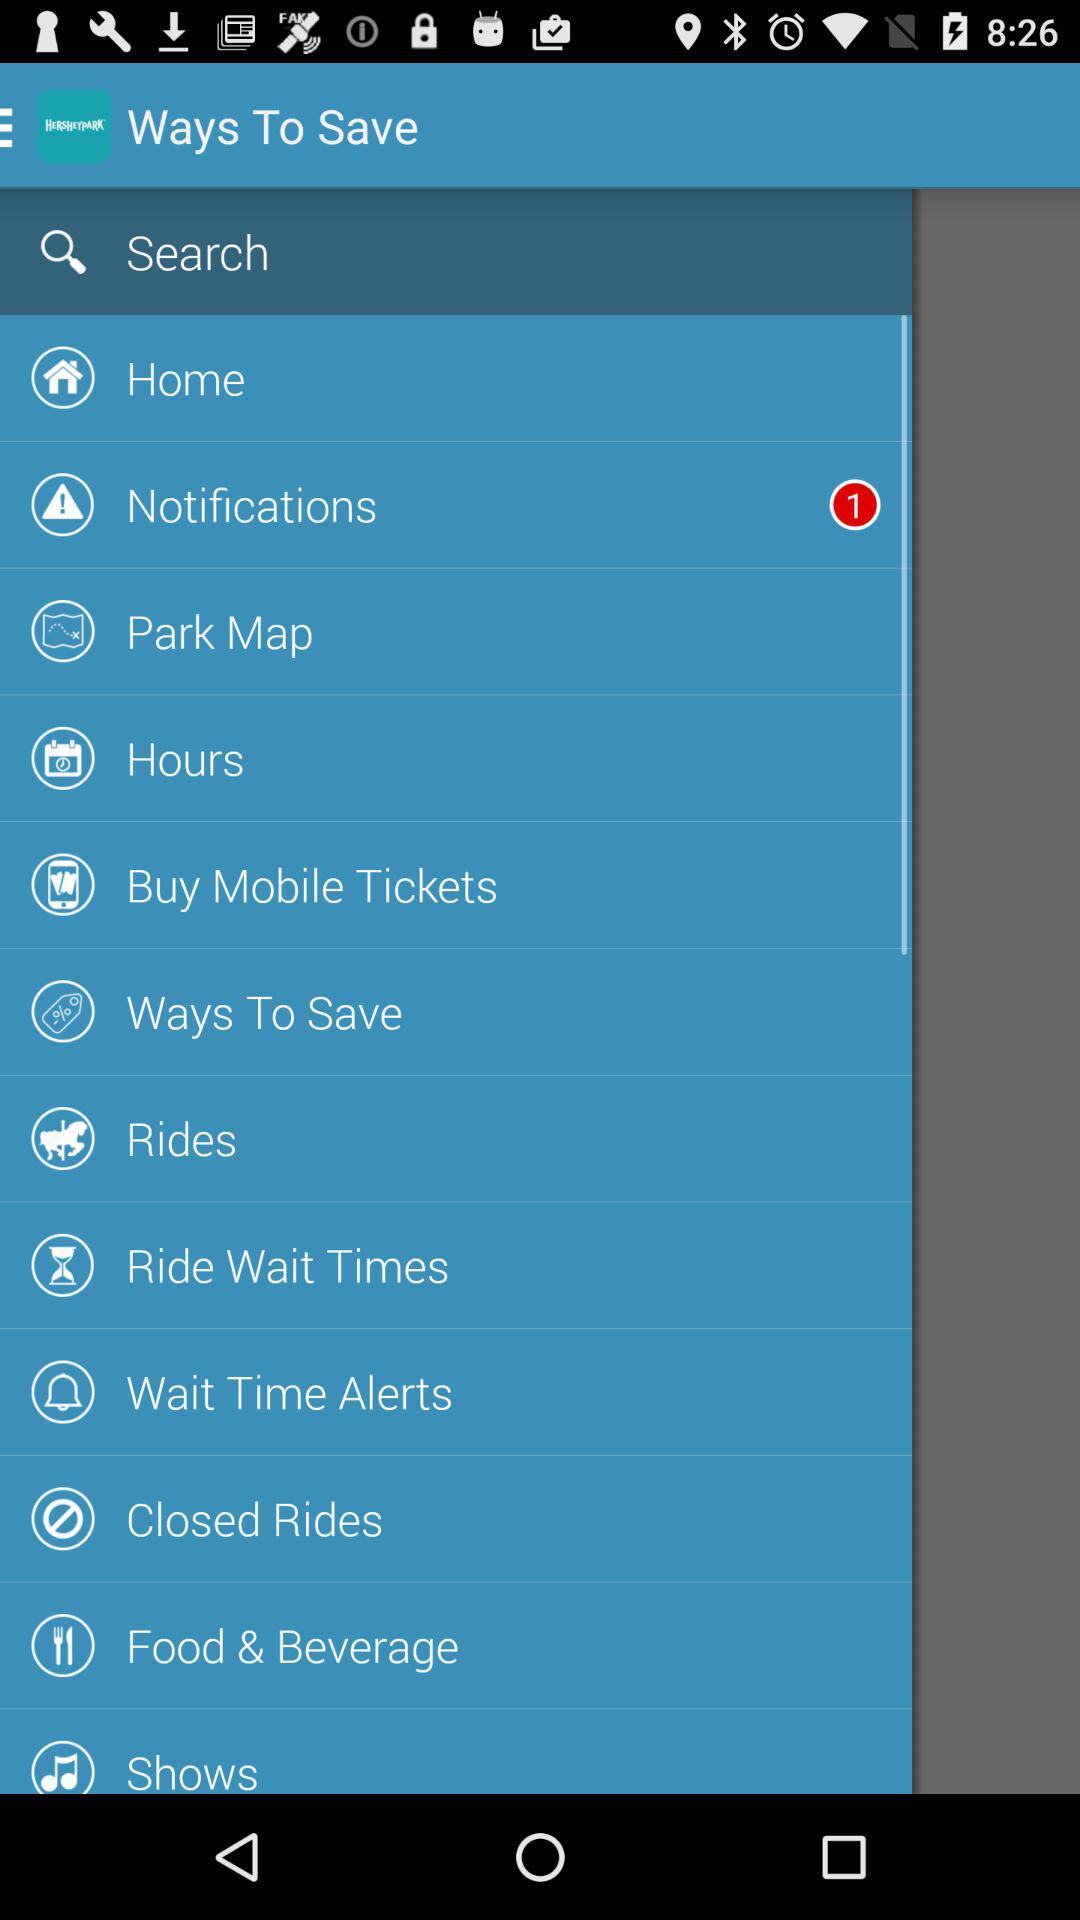How many notifications are pending? There is 1 pending notification. 